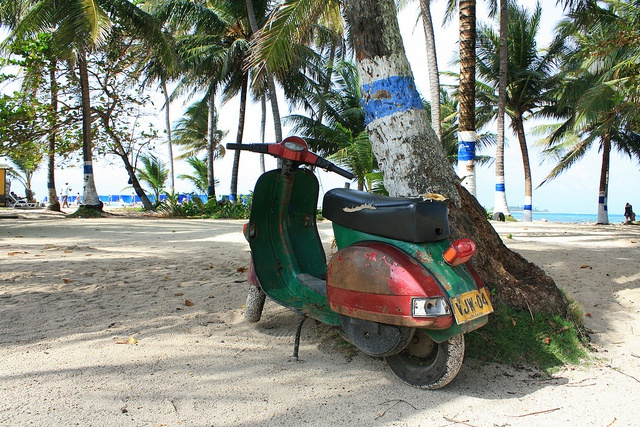Describe the objects in this image and their specific colors. I can see motorcycle in darkgreen, black, gray, maroon, and teal tones, people in darkgreen, white, lightblue, gray, and brown tones, people in darkgreen, black, maroon, gray, and lightblue tones, people in darkgreen, white, darkgray, tan, and gray tones, and people in darkgreen, black, maroon, gray, and blue tones in this image. 